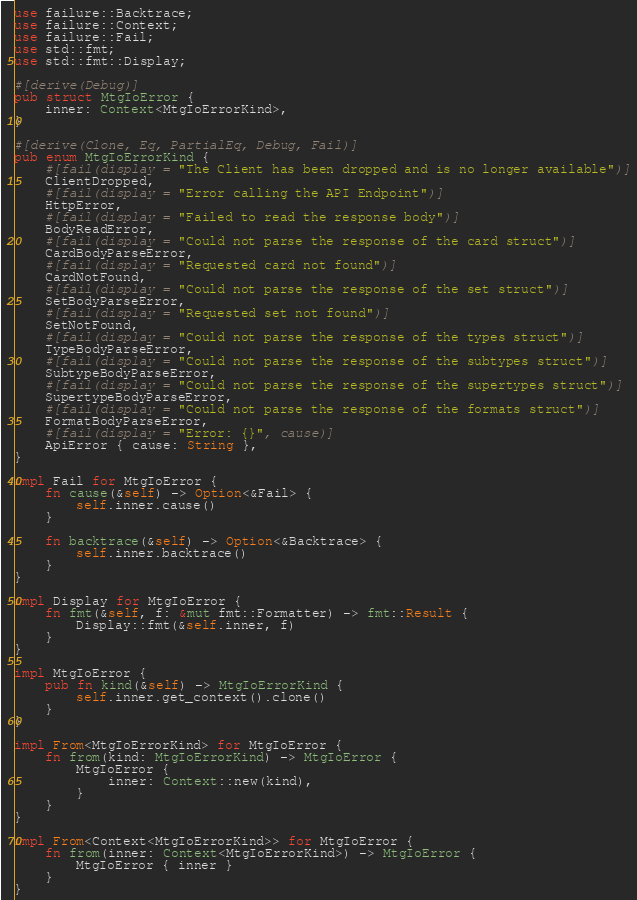Convert code to text. <code><loc_0><loc_0><loc_500><loc_500><_Rust_>use failure::Backtrace;
use failure::Context;
use failure::Fail;
use std::fmt;
use std::fmt::Display;

#[derive(Debug)]
pub struct MtgIoError {
    inner: Context<MtgIoErrorKind>,
}

#[derive(Clone, Eq, PartialEq, Debug, Fail)]
pub enum MtgIoErrorKind {
    #[fail(display = "The Client has been dropped and is no longer available")]
    ClientDropped,
    #[fail(display = "Error calling the API Endpoint")]
    HttpError,
    #[fail(display = "Failed to read the response body")]
    BodyReadError,
    #[fail(display = "Could not parse the response of the card struct")]
    CardBodyParseError,
    #[fail(display = "Requested card not found")]
    CardNotFound,
    #[fail(display = "Could not parse the response of the set struct")]
    SetBodyParseError,
    #[fail(display = "Requested set not found")]
    SetNotFound,
    #[fail(display = "Could not parse the response of the types struct")]
    TypeBodyParseError,
    #[fail(display = "Could not parse the response of the subtypes struct")]
    SubtypeBodyParseError,
    #[fail(display = "Could not parse the response of the supertypes struct")]
    SupertypeBodyParseError,
    #[fail(display = "Could not parse the response of the formats struct")]
    FormatBodyParseError,
    #[fail(display = "Error: {}", cause)]
    ApiError { cause: String },
}

impl Fail for MtgIoError {
    fn cause(&self) -> Option<&Fail> {
        self.inner.cause()
    }

    fn backtrace(&self) -> Option<&Backtrace> {
        self.inner.backtrace()
    }
}

impl Display for MtgIoError {
    fn fmt(&self, f: &mut fmt::Formatter) -> fmt::Result {
        Display::fmt(&self.inner, f)
    }
}

impl MtgIoError {
    pub fn kind(&self) -> MtgIoErrorKind {
        self.inner.get_context().clone()
    }
}

impl From<MtgIoErrorKind> for MtgIoError {
    fn from(kind: MtgIoErrorKind) -> MtgIoError {
        MtgIoError {
            inner: Context::new(kind),
        }
    }
}

impl From<Context<MtgIoErrorKind>> for MtgIoError {
    fn from(inner: Context<MtgIoErrorKind>) -> MtgIoError {
        MtgIoError { inner }
    }
}
</code> 